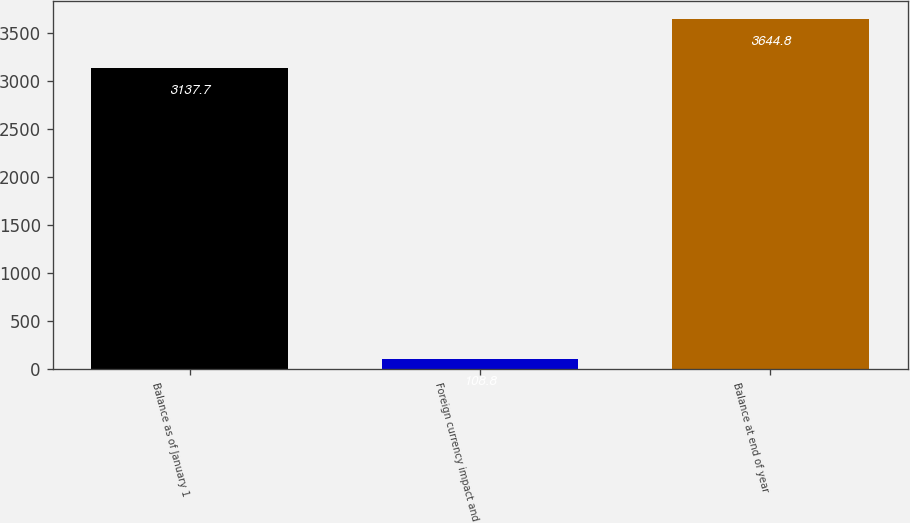Convert chart. <chart><loc_0><loc_0><loc_500><loc_500><bar_chart><fcel>Balance as of January 1<fcel>Foreign currency impact and<fcel>Balance at end of year<nl><fcel>3137.7<fcel>108.8<fcel>3644.8<nl></chart> 